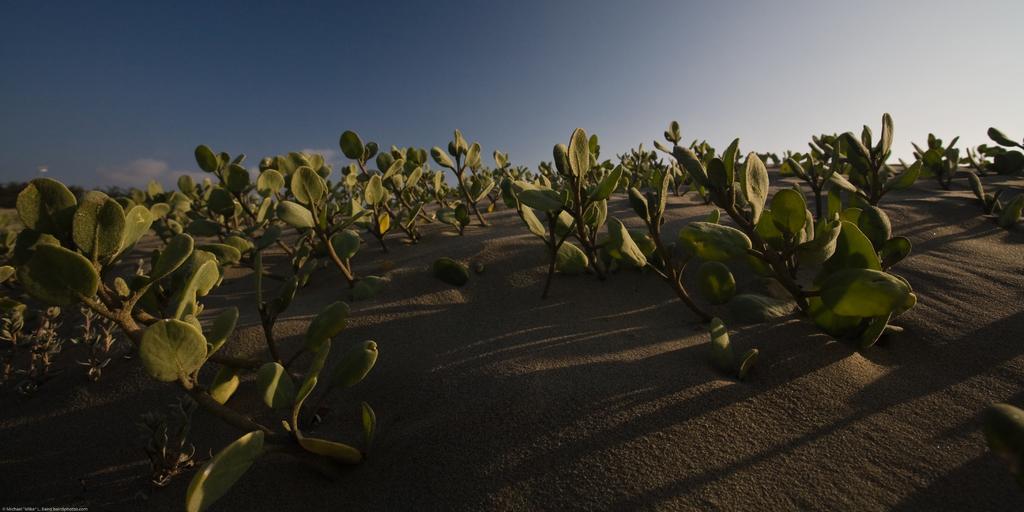In one or two sentences, can you explain what this image depicts? In this image I can see plants in a farm. At the top I can see the sky. This image is taken may be in a farm during evening. 